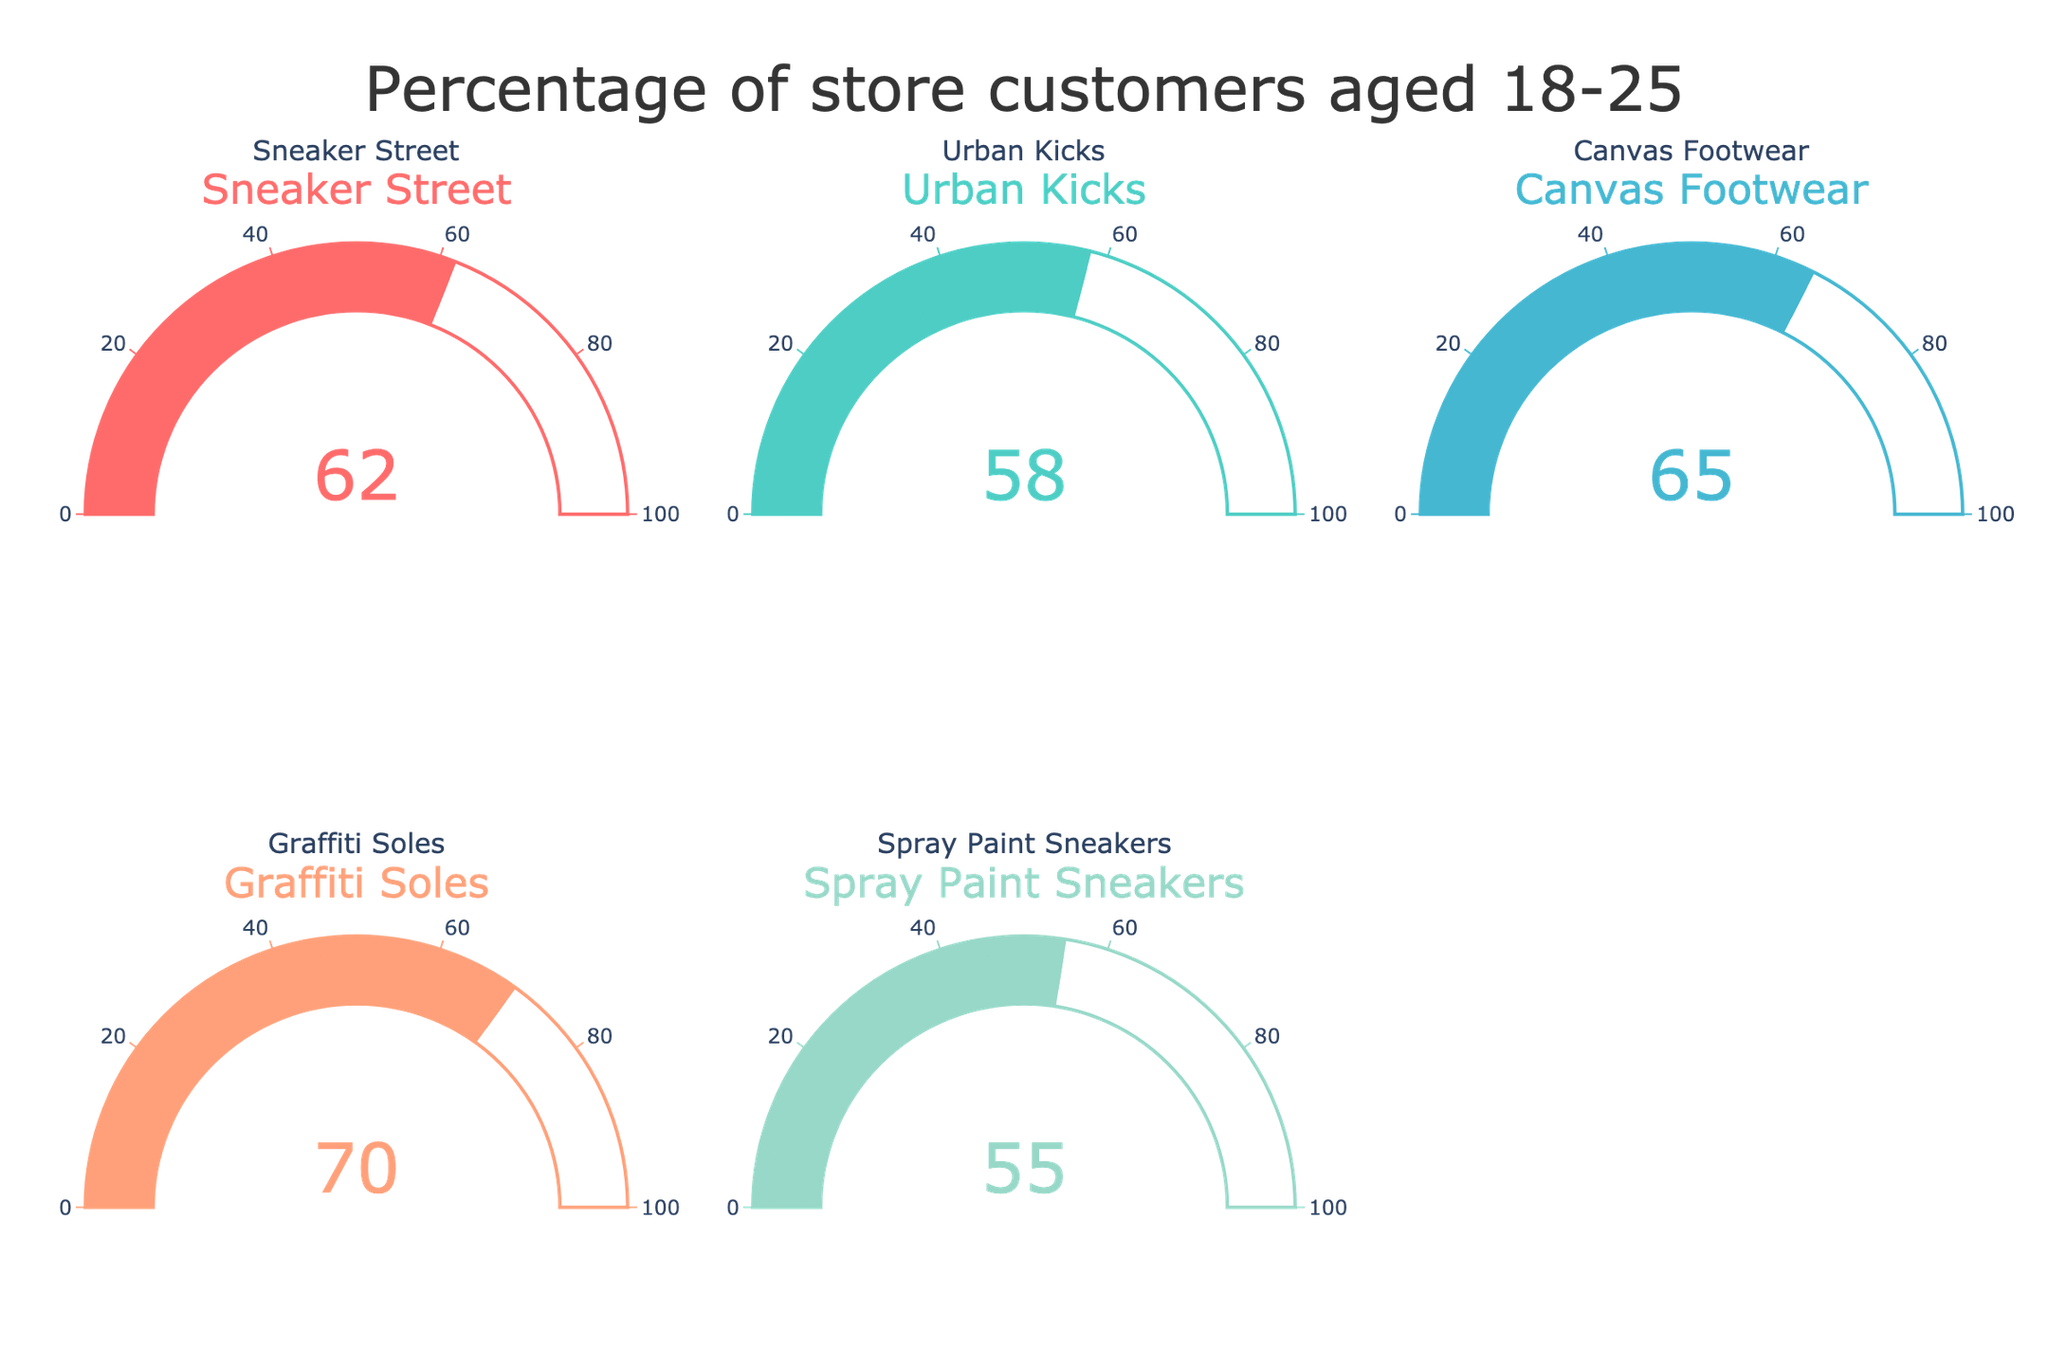What's the title of the figure? The title is usually displayed at the top of the figure, indicating the main topic or focus. In this case, it would be near the top-center of the figure.
Answer: Percentage of store customers aged 18-25 How many stores are displayed in the figure? There are gauges for each store in the figure. By counting the number of gauges (typically arranged in rows and columns), you can determine the number of stores.
Answer: 5 Which store has the highest percentage of customers aged 18-25? By examining each gauge, you can compare the percentages. The store with the largest number on its gauge has the highest percentage.
Answer: Graffiti Soles Which store has the lowest percentage of customers aged 18-25? Similar to finding the highest percentage, look for the store with the smallest number on its gauge.
Answer: Spray Paint Sneakers What is the average percentage of customers aged 18-25 across all the stores? Sum the percentages of all stores and then divide by the total number of stores: (62+58+65+70+55) / 5 = 310 / 5 = 62
Answer: 62 What is the difference in the percentage of customers aged 18-25 between Graffiti Soles and Urban Kicks? Subtract the percentage of Urban Kicks from the percentage of Graffiti Soles: 70 - 58 = 12
Answer: 12 What is the median percentage of customers aged 18-25 across all the stores? Organize the percentages in ascending order and select the middle value: 55, 58, 62, 65, 70. The middle value is 62.
Answer: 62 Does any store have exactly 60% customers aged 18-25? Carefully inspect each gauge for the exact percentage value of 60%.
Answer: No How many stores have a percentage of customers aged 18-25 greater than 60%? Count the number of gauges displaying a number greater than 60. There are three such stores (Sneaker Street, Canvas Footwear, and Graffiti Soles).
Answer: 3 What is the visual color scheme used for the gauges? The colors are typically visible in the figure and can be described based on their appearance. They are vibrant and may include shades like red, green, blue, orange, and light blue.
Answer: Vibrant colors - red, green, blue, orange, and light blue 